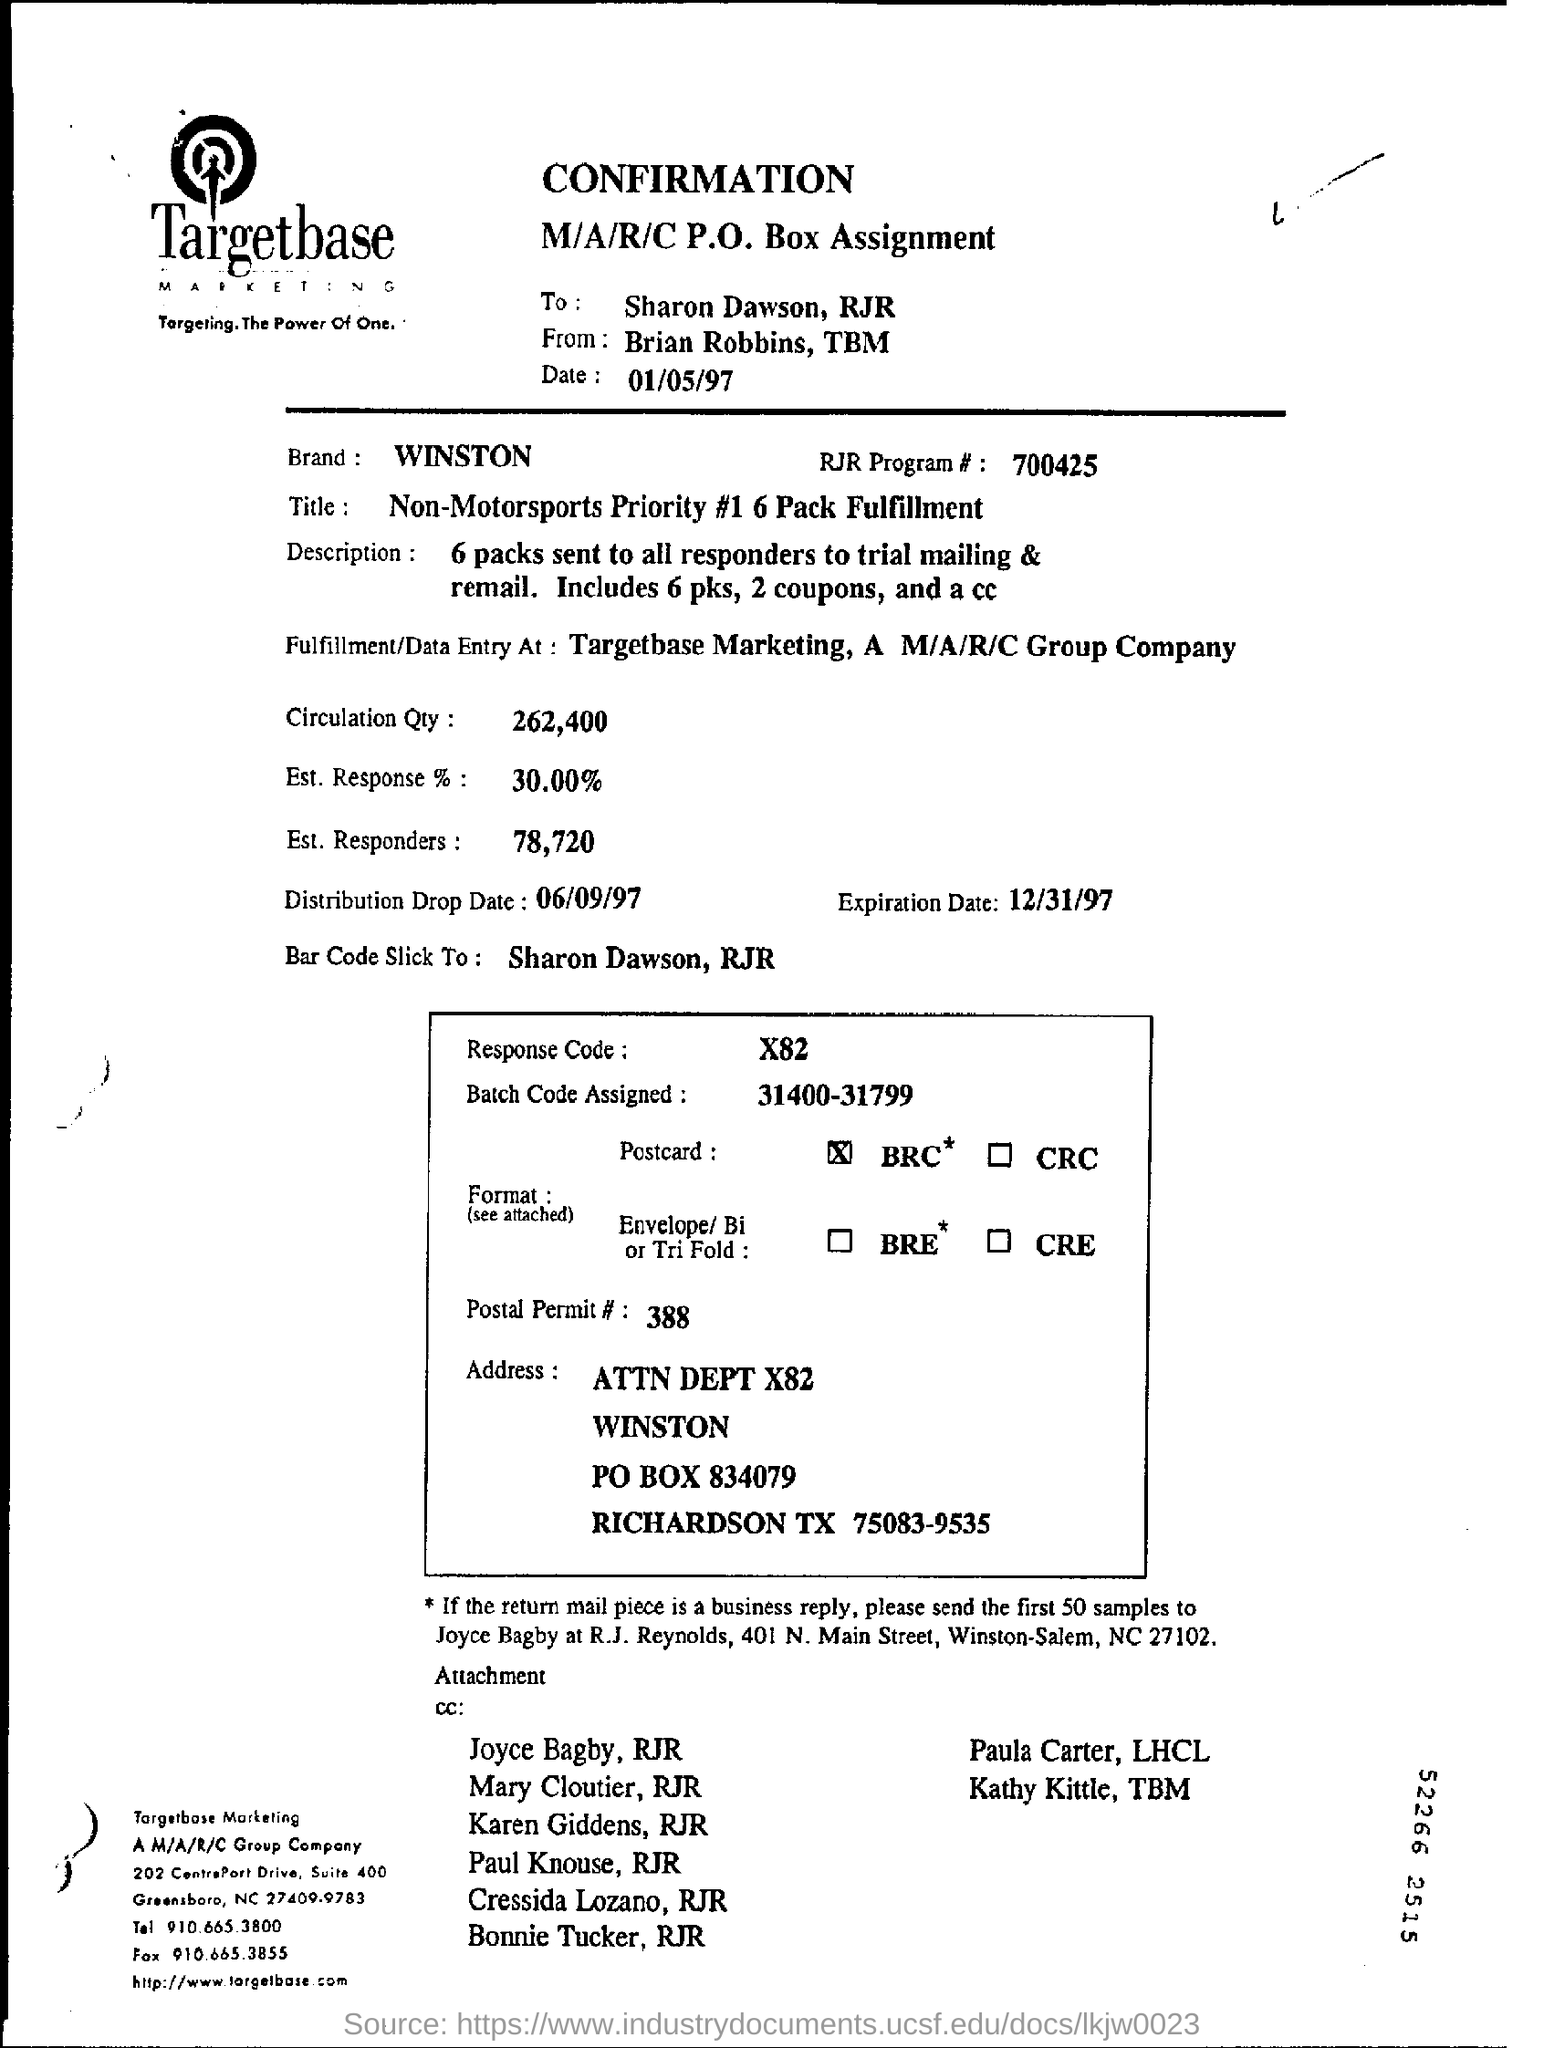What is the brand name?
Ensure brevity in your answer.  WINSTON. What is the "RJR program #" number?
Ensure brevity in your answer.  700425. What is the RJR Brand given in the form?
Offer a very short reply. WINSTON. What is the "circulation Quantity" ?
Offer a very short reply. 262,400. What is the percentage of "Est.response" ?
Make the answer very short. 30.00. What is the percentage of "Est.responders" ?
Give a very brief answer. 78,720. What is the distribution drop date?
Your response must be concise. 06/09/97. What is the expiration date ?
Make the answer very short. 12/31/97. What is the response Code?
Provide a short and direct response. X82. 